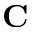<formula> <loc_0><loc_0><loc_500><loc_500>C</formula> 